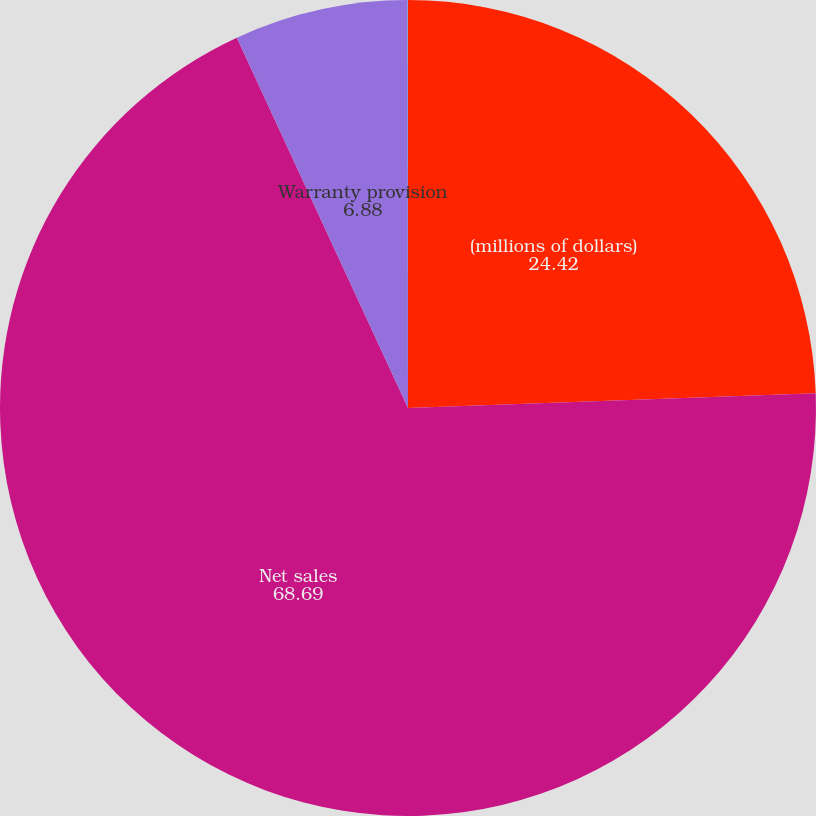<chart> <loc_0><loc_0><loc_500><loc_500><pie_chart><fcel>(millions of dollars)<fcel>Net sales<fcel>Warranty provision<fcel>Warranty provision as a<nl><fcel>24.42%<fcel>68.69%<fcel>6.88%<fcel>0.01%<nl></chart> 